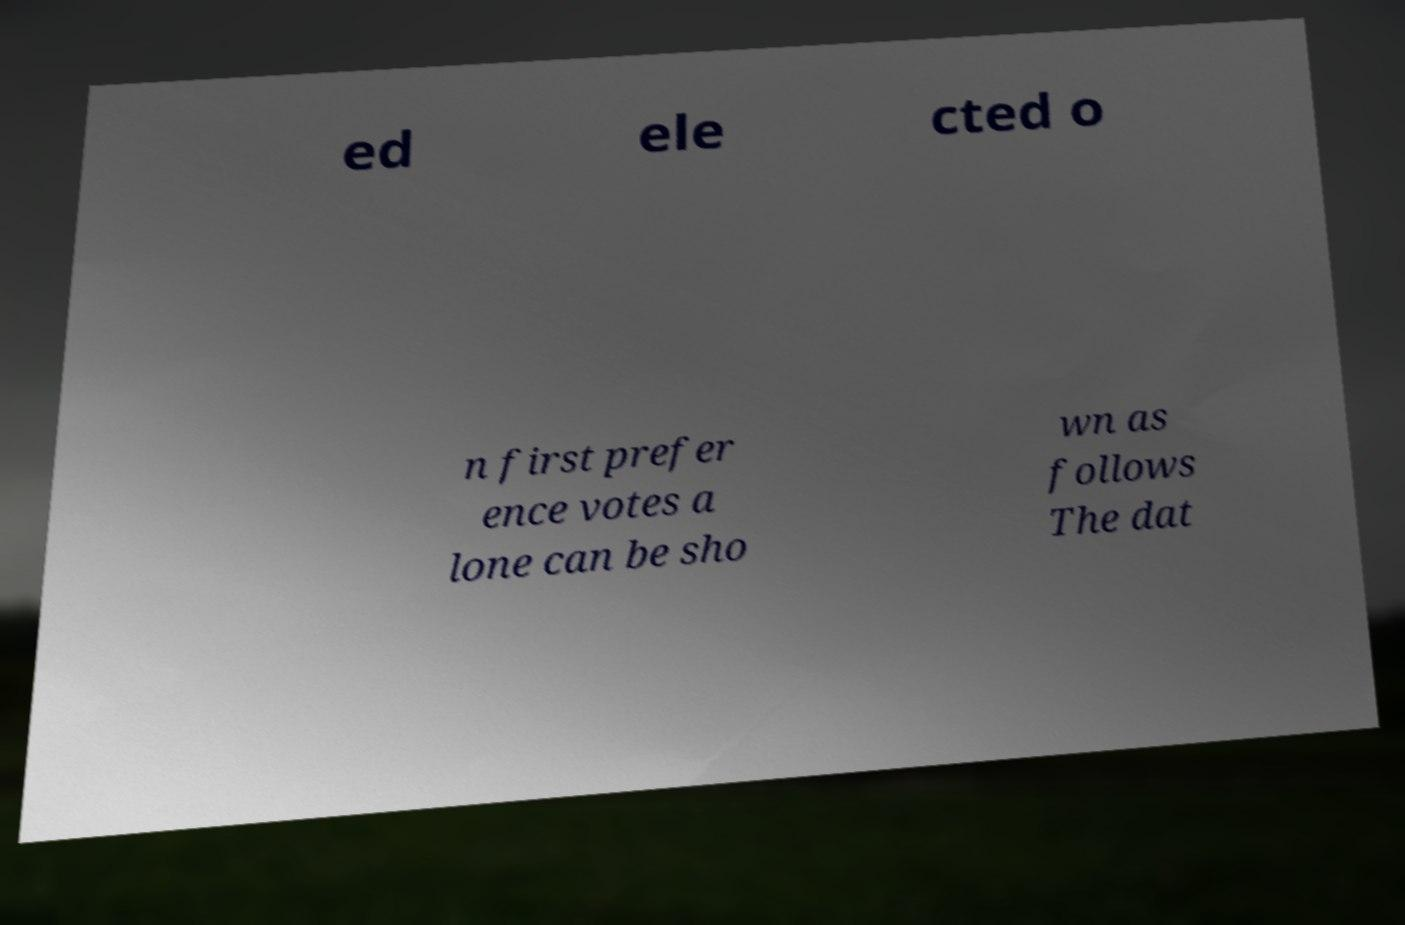There's text embedded in this image that I need extracted. Can you transcribe it verbatim? ed ele cted o n first prefer ence votes a lone can be sho wn as follows The dat 